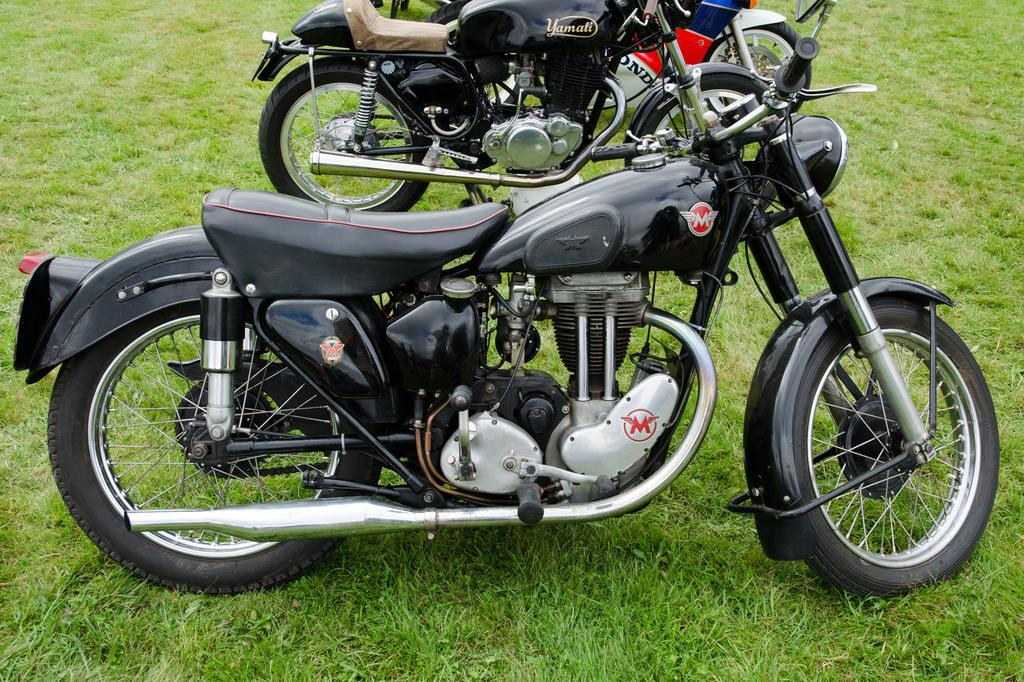What type of natural feature can be seen in the image? There are lakes (or bodies of water) in the image. What type of vegetation is present on the ground in the image? There is grass on the ground in the image. What type of table is depicted in the image? There is no table present in the image; it features lakes (or bodies of water) and grass. What religious beliefs are represented in the image? The image does not depict any religious beliefs; it features lakes (or bodies of water) and grass. 